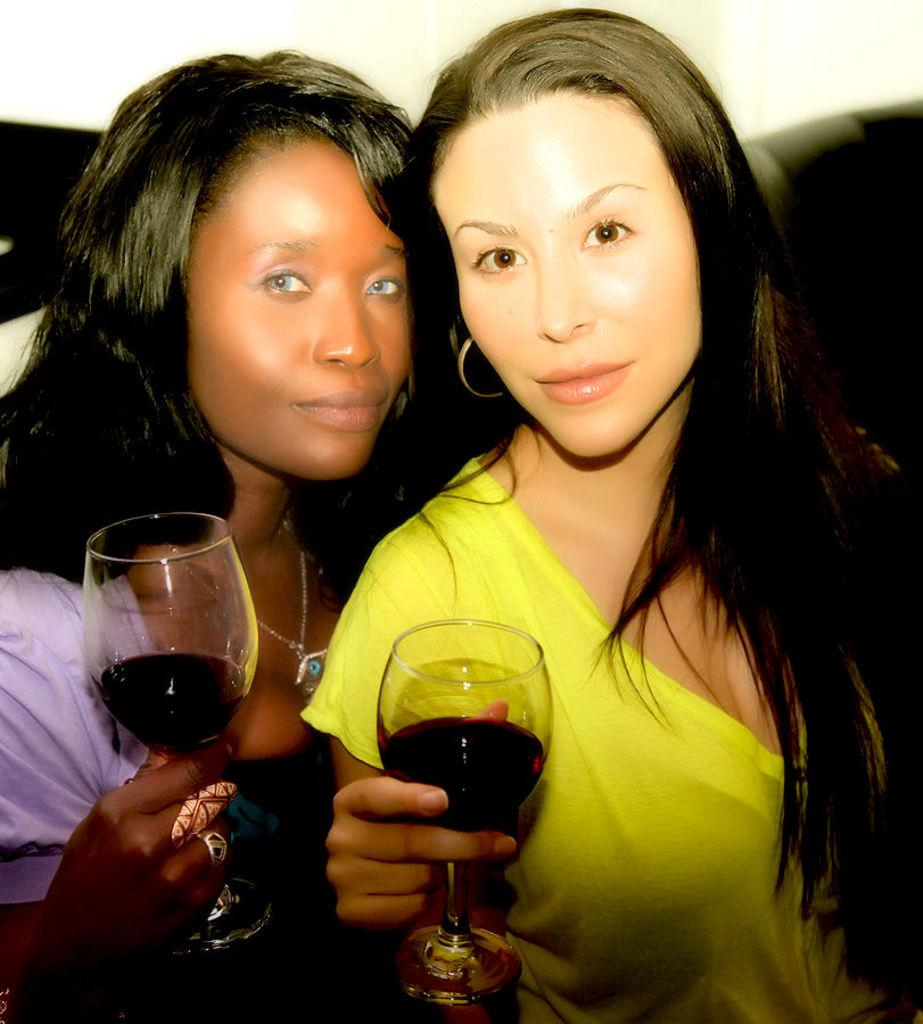How many women are in the image? There are two women in the image. What are the women holding in the image? Both women are holding wine glasses. Can you describe the clothing of the first woman? The first woman is wearing a blue T-shirt. How about the second woman? The second woman is wearing a yellow T-shirt. What can be seen in the background of the image? There is a wall in the background of the image. What type of vest is the woman wearing in the image? There is no vest present in the image; both women are wearing T-shirts. How many sacks can be seen in the image? There are no sacks present in the image. 